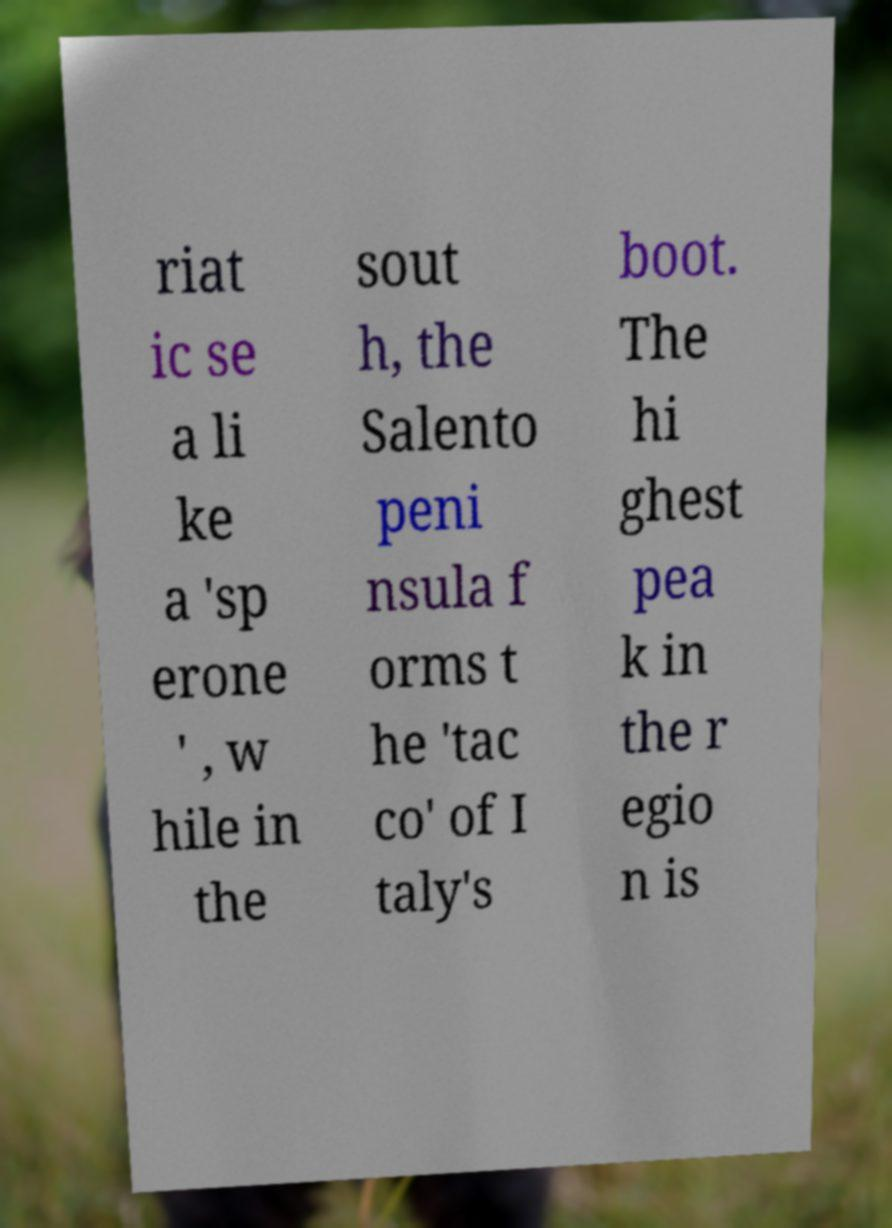Please identify and transcribe the text found in this image. riat ic se a li ke a 'sp erone ' , w hile in the sout h, the Salento peni nsula f orms t he 'tac co' of I taly's boot. The hi ghest pea k in the r egio n is 